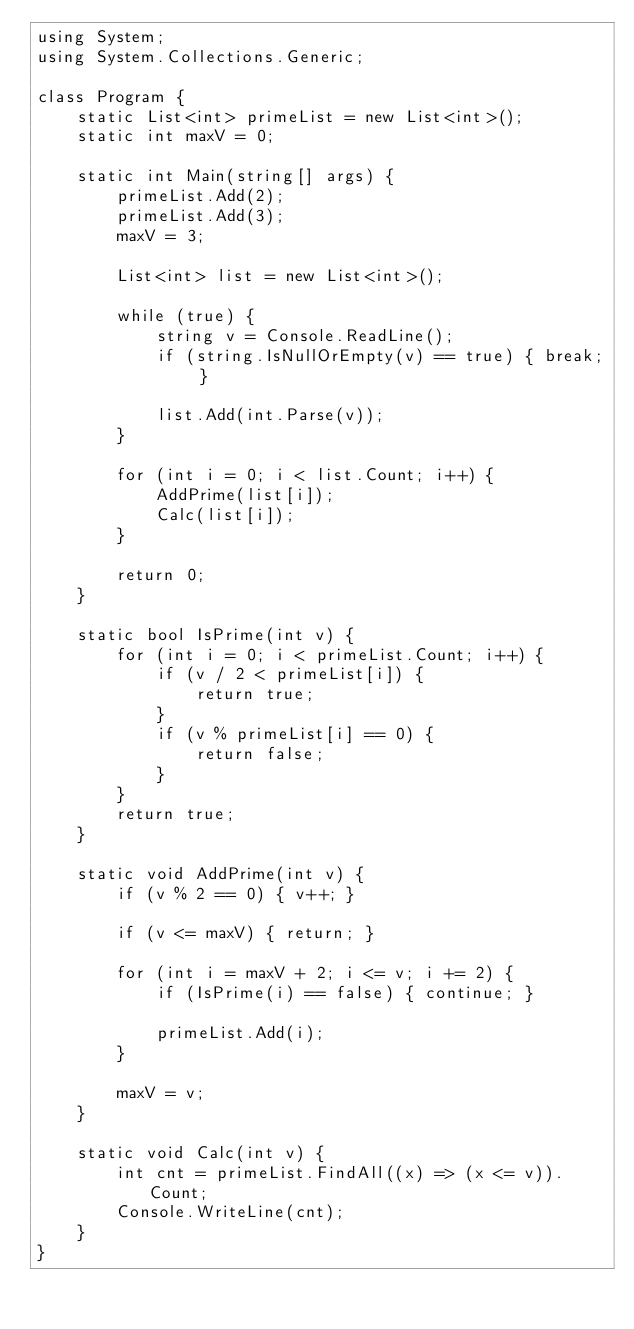Convert code to text. <code><loc_0><loc_0><loc_500><loc_500><_C#_>using System;
using System.Collections.Generic;

class Program {
    static List<int> primeList = new List<int>();
    static int maxV = 0;

    static int Main(string[] args) {
        primeList.Add(2);
        primeList.Add(3);
        maxV = 3;

        List<int> list = new List<int>();

        while (true) {
            string v = Console.ReadLine();
            if (string.IsNullOrEmpty(v) == true) { break; }

            list.Add(int.Parse(v));
        }

        for (int i = 0; i < list.Count; i++) {
            AddPrime(list[i]);
            Calc(list[i]);
        }

        return 0;
    }

    static bool IsPrime(int v) {
        for (int i = 0; i < primeList.Count; i++) {
            if (v / 2 < primeList[i]) {
                return true;
            }
            if (v % primeList[i] == 0) {
                return false;
            }
        }
        return true;
    }

    static void AddPrime(int v) {
        if (v % 2 == 0) { v++; }

        if (v <= maxV) { return; }

        for (int i = maxV + 2; i <= v; i += 2) {
            if (IsPrime(i) == false) { continue; }

            primeList.Add(i);
        }

        maxV = v;
    }

    static void Calc(int v) {
        int cnt = primeList.FindAll((x) => (x <= v)).Count;
        Console.WriteLine(cnt);
    }
}</code> 